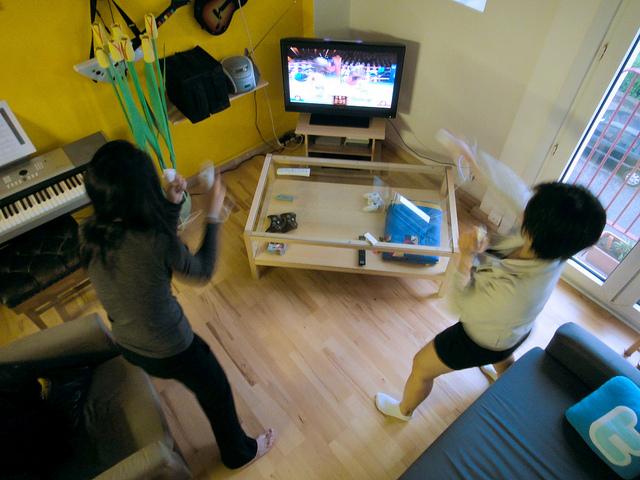Where is the television?
Keep it brief. In corner. Does that coffee table have a glass top?
Write a very short answer. Yes. What musical instrument is present?
Short answer required. Piano. 